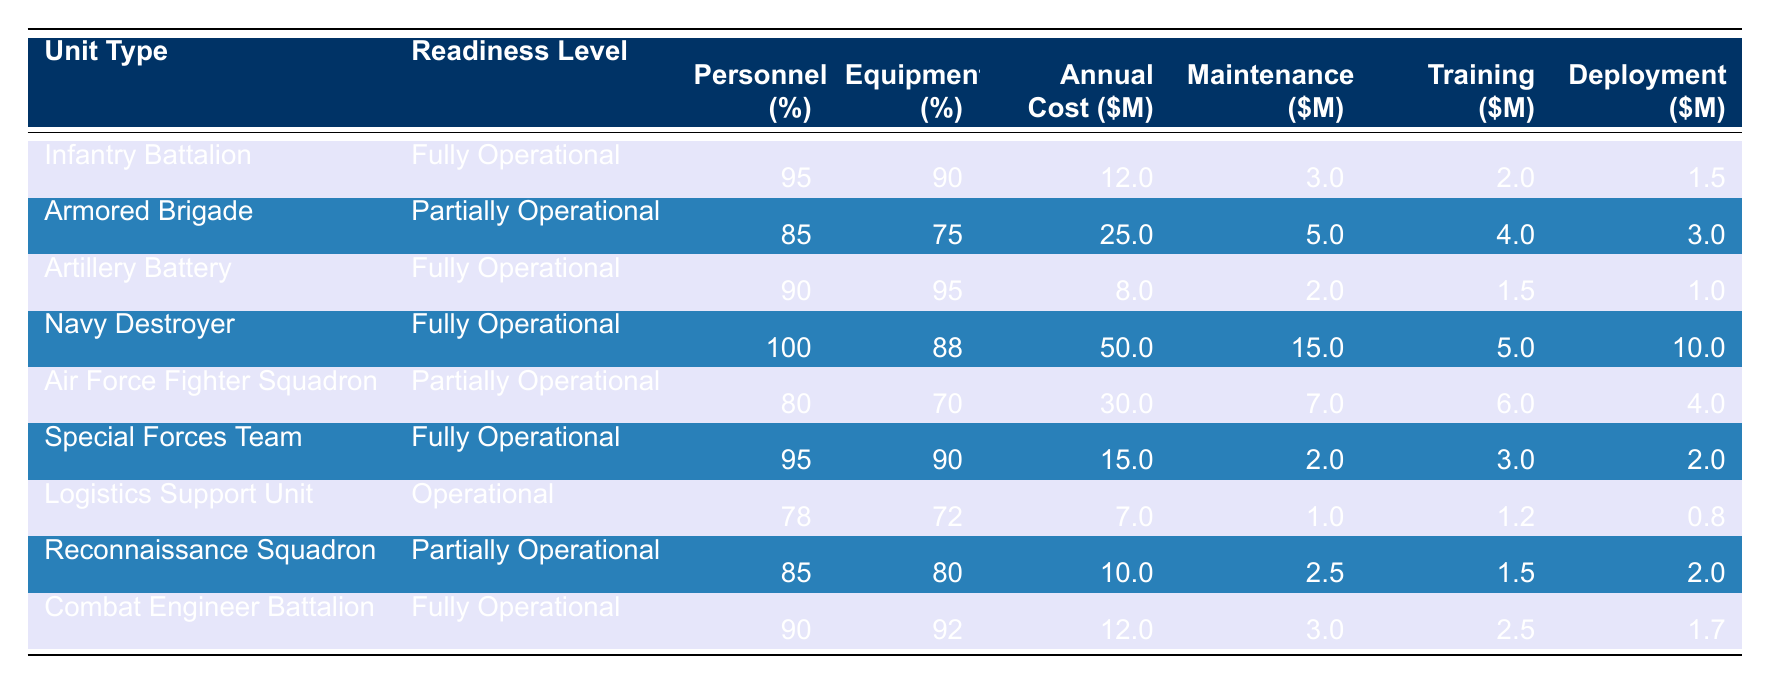What is the personnel availability percentage of the Navy Destroyer? The table lists the personnel availability for the Navy Destroyer, showing it to be 100%.
Answer: 100% What is the annual operating cost of the Armored Brigade? By looking at the Armored Brigade row, the annual operating cost is specified as 25 million dollars.
Answer: 25 million Which unit type has the lowest equipment availability percentage? The Logistics Support Unit has the lowest equipment availability at 72%, as per the values in the table.
Answer: 72% What is the total annual operating cost of all units classified as Fully Operational? The annual operating costs for Fully Operational units are: Infantry Battalion (12M) + Artillery Battery (8M) + Navy Destroyer (50M) + Special Forces Team (15M) + Combat Engineer Battalion (12M), adding these gives 97 million dollars.
Answer: 97 million Which unit type has the highest maintenance cost? The Navy Destroyer has a maintenance cost of 15 million dollars, which is greater than the other listed units.
Answer: Navy Destroyer What is the average personnel availability percentage across all the units? First, sum the personnel availability percentages which are 95 + 85 + 90 + 100 + 80 + 95 + 78 + 85 + 90 = 810. Then divide by the number of units (9), which gives an average of about 90%.
Answer: 90% Is the Air Force Fighter Squadron fully operational? No, the Air Force Fighter Squadron is classified as partially operational, according to the table.
Answer: No What is the difference in annual operating costs between the Navy Destroyer and the Logistics Support Unit? The Navy Destroyer costs 50 million dollars, and the Logistics Support Unit costs 7 million dollars. The difference is calculated as 50M - 7M = 43 million dollars.
Answer: 43 million Which units have both personnel and equipment availability above 90%? The units that meet this criterion are the Navy Destroyer, Artillery Battery, and Special Forces Team, as they all show both percentages above 90%.
Answer: Navy Destroyer, Artillery Battery, Special Forces Team What is the total training cost for units that are classified as partially operational? The training costs for partially operational units are: Armored Brigade (4M) + Air Force Fighter Squadron (6M) + Reconnaissance Squadron (1.5M). Their total adds up to 11.5 million dollars.
Answer: 11.5 million 